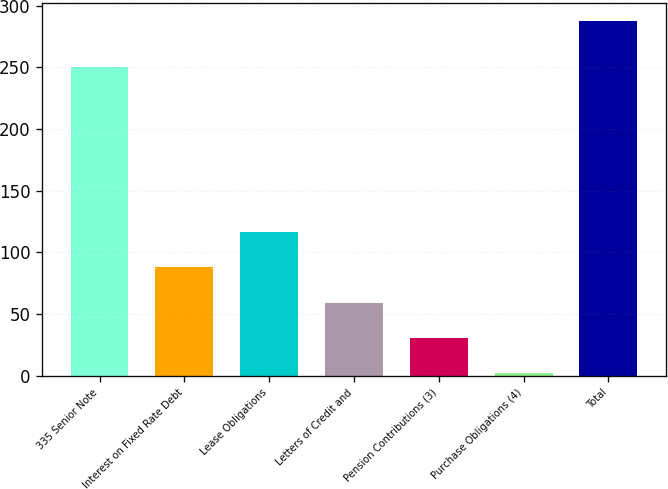Convert chart. <chart><loc_0><loc_0><loc_500><loc_500><bar_chart><fcel>335 Senior Note<fcel>Interest on Fixed Rate Debt<fcel>Lease Obligations<fcel>Letters of Credit and<fcel>Pension Contributions (3)<fcel>Purchase Obligations (4)<fcel>Total<nl><fcel>250<fcel>87.76<fcel>116.28<fcel>59.24<fcel>30.72<fcel>2.2<fcel>287.4<nl></chart> 